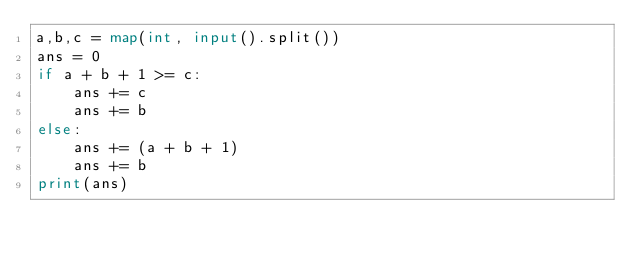<code> <loc_0><loc_0><loc_500><loc_500><_Python_>a,b,c = map(int, input().split())
ans = 0
if a + b + 1 >= c:
    ans += c
    ans += b
else:
    ans += (a + b + 1)
    ans += b
print(ans)


</code> 